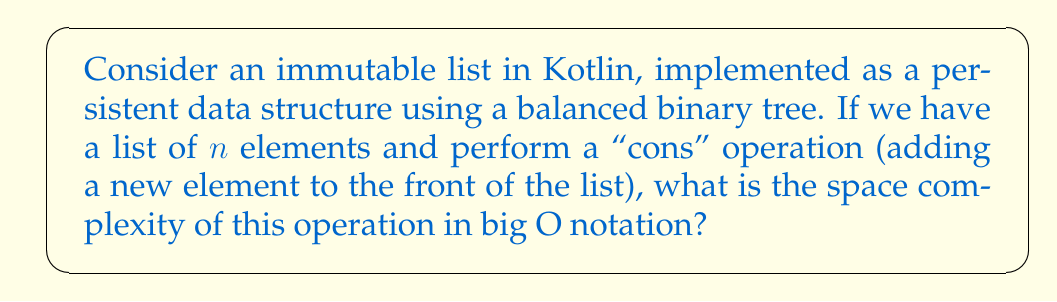Help me with this question. To analyze the space complexity of the "cons" operation on an immutable list in Kotlin, we need to consider how persistent data structures work:

1. In a persistent data structure, each operation creates a new version of the data structure without modifying the original.

2. For an immutable list implemented as a balanced binary tree:
   - Each node contains an element and references to left and right child nodes.
   - The tree is balanced, so its height is $O(\log n)$ where $n$ is the number of elements.

3. When performing a "cons" operation:
   - We create a new root node containing the new element.
   - We reuse the existing tree structure for the rest of the elements.
   - We only need to create new nodes along the path from the root to the appropriate leaf.

4. The number of new nodes created is equal to the height of the tree:
   $$\text{New nodes} = O(\log n)$$

5. Each node typically contains:
   - The element (constant space)
   - Two references to child nodes (constant space)

6. Therefore, the total additional space required is:
   $$O(\log n) \times O(1) = O(\log n)$$

This logarithmic space complexity is what makes persistent data structures efficient for functional programming languages like Kotlin, as it allows for immutability without sacrificing too much performance.
Answer: The space complexity of the "cons" operation on an immutable list in Kotlin, implemented as a persistent balanced binary tree, is $O(\log n)$. 